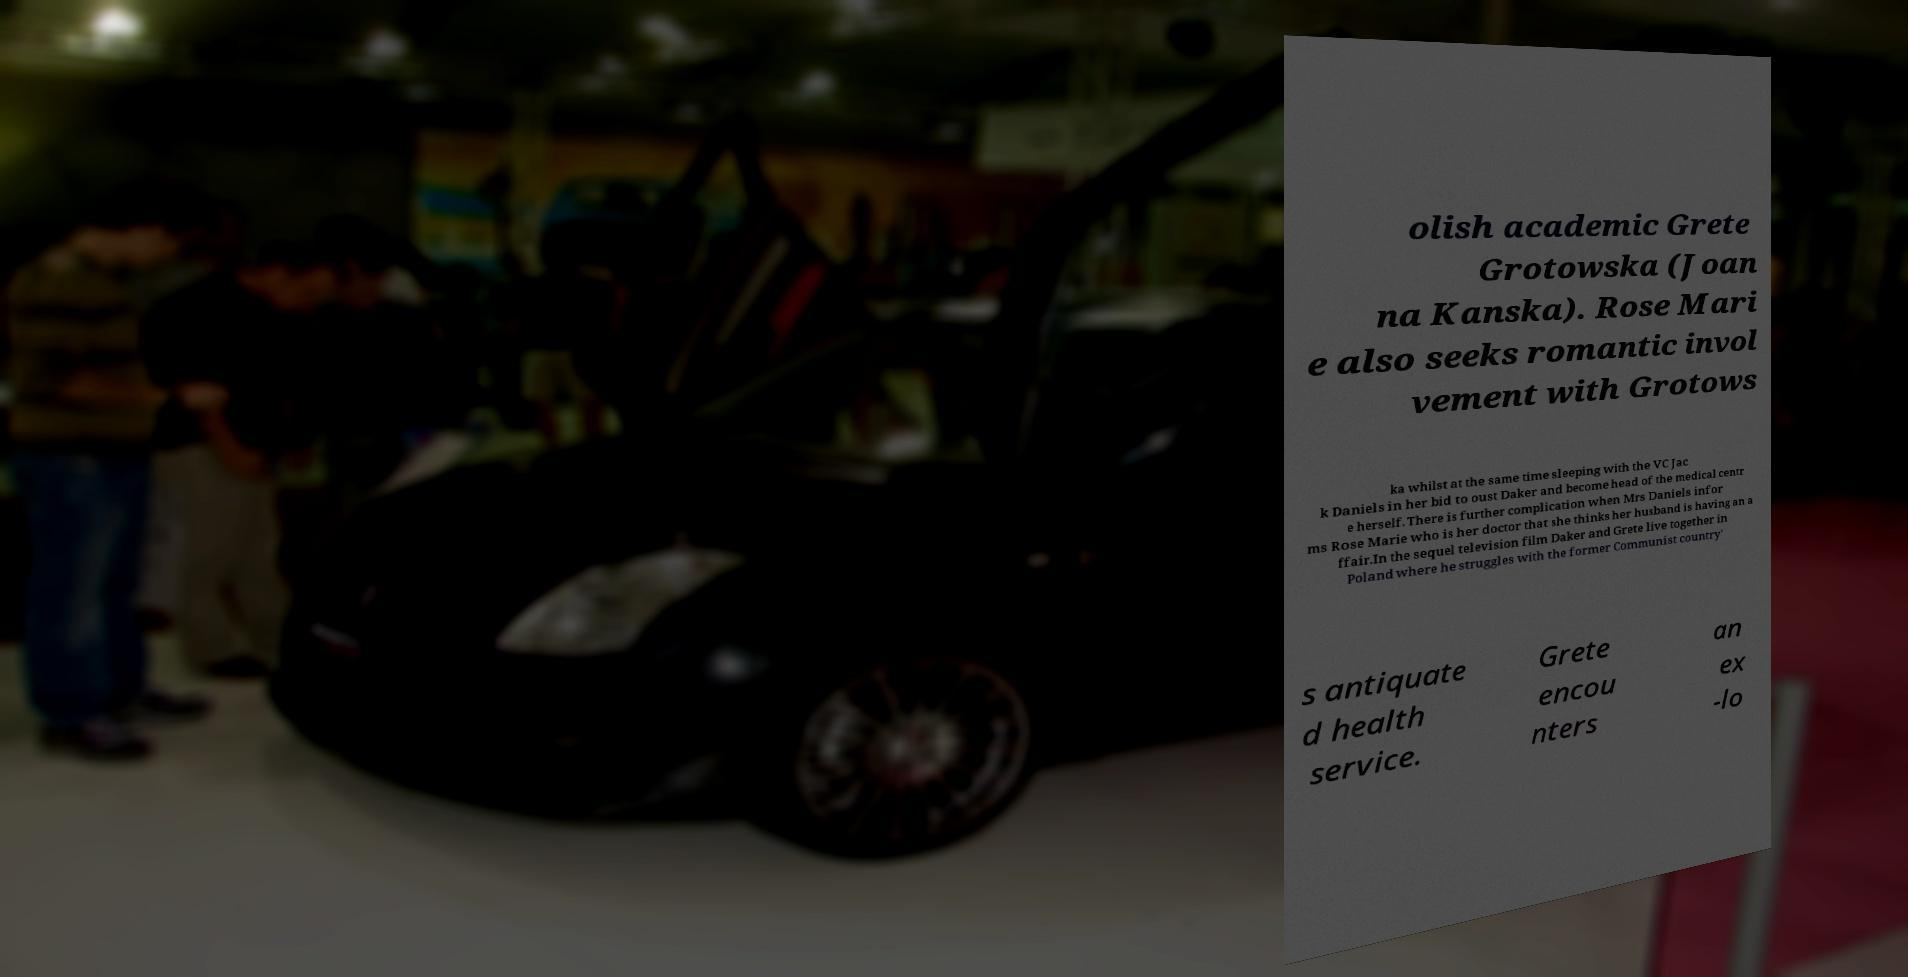Could you assist in decoding the text presented in this image and type it out clearly? olish academic Grete Grotowska (Joan na Kanska). Rose Mari e also seeks romantic invol vement with Grotows ka whilst at the same time sleeping with the VC Jac k Daniels in her bid to oust Daker and become head of the medical centr e herself. There is further complication when Mrs Daniels infor ms Rose Marie who is her doctor that she thinks her husband is having an a ffair.In the sequel television film Daker and Grete live together in Poland where he struggles with the former Communist country' s antiquate d health service. Grete encou nters an ex -lo 